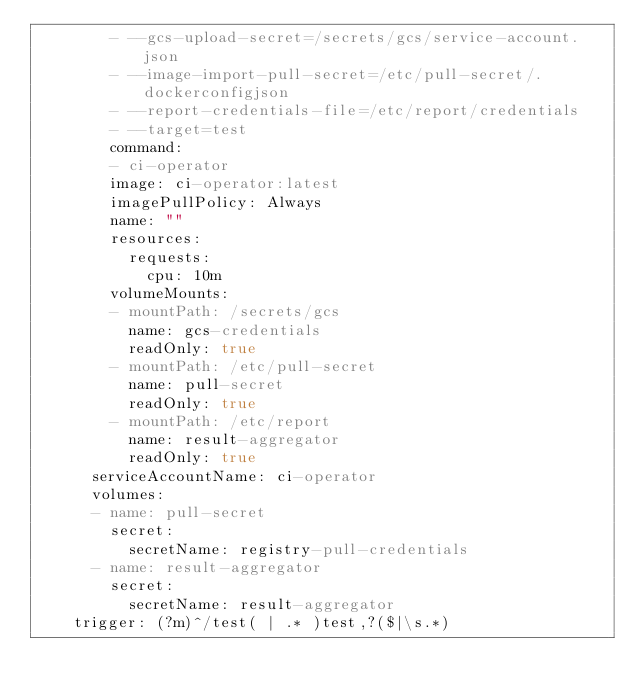Convert code to text. <code><loc_0><loc_0><loc_500><loc_500><_YAML_>        - --gcs-upload-secret=/secrets/gcs/service-account.json
        - --image-import-pull-secret=/etc/pull-secret/.dockerconfigjson
        - --report-credentials-file=/etc/report/credentials
        - --target=test
        command:
        - ci-operator
        image: ci-operator:latest
        imagePullPolicy: Always
        name: ""
        resources:
          requests:
            cpu: 10m
        volumeMounts:
        - mountPath: /secrets/gcs
          name: gcs-credentials
          readOnly: true
        - mountPath: /etc/pull-secret
          name: pull-secret
          readOnly: true
        - mountPath: /etc/report
          name: result-aggregator
          readOnly: true
      serviceAccountName: ci-operator
      volumes:
      - name: pull-secret
        secret:
          secretName: registry-pull-credentials
      - name: result-aggregator
        secret:
          secretName: result-aggregator
    trigger: (?m)^/test( | .* )test,?($|\s.*)
</code> 